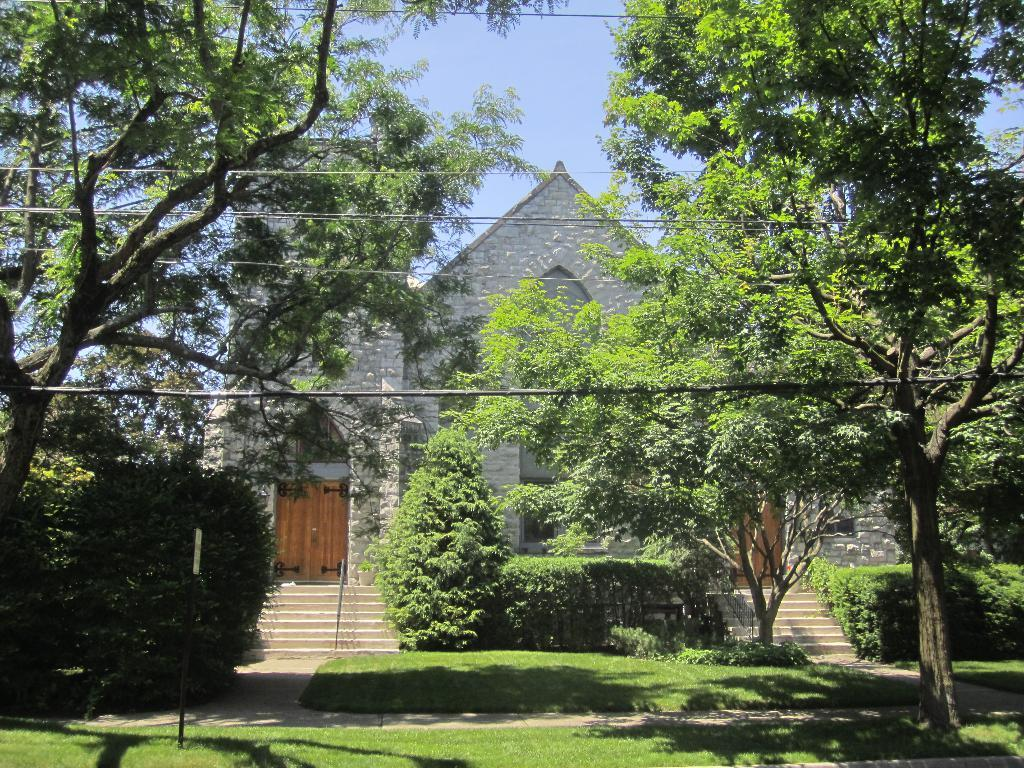What type of structure is visible in the image? There is a building in the image. What type of vegetation can be seen in the image? There are trees in the image. What is covering the ground in the image? There is grass on the ground in the image. What is attached to the pole in the image? There is a board on a pole in the image. What color is the sky in the image? The sky is blue in the image. What type of spot can be seen on the building in the image? There is no spot visible on the building in the image. What show is being performed in the image? There is no show being performed in the image. 